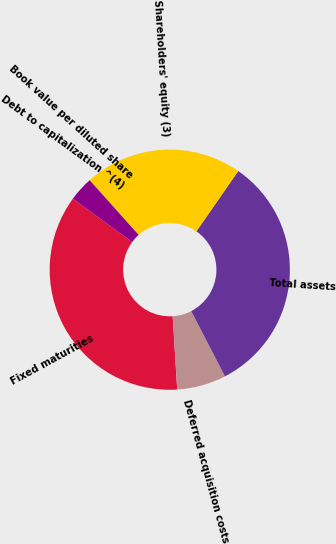<chart> <loc_0><loc_0><loc_500><loc_500><pie_chart><fcel>Fixed maturities<fcel>Deferred acquisition costs<fcel>Total assets<fcel>Shareholders' equity (3)<fcel>Book value per diluted share<fcel>Debt to capitalization ^(4)<nl><fcel>36.05%<fcel>6.61%<fcel>32.74%<fcel>21.28%<fcel>3.31%<fcel>0.0%<nl></chart> 